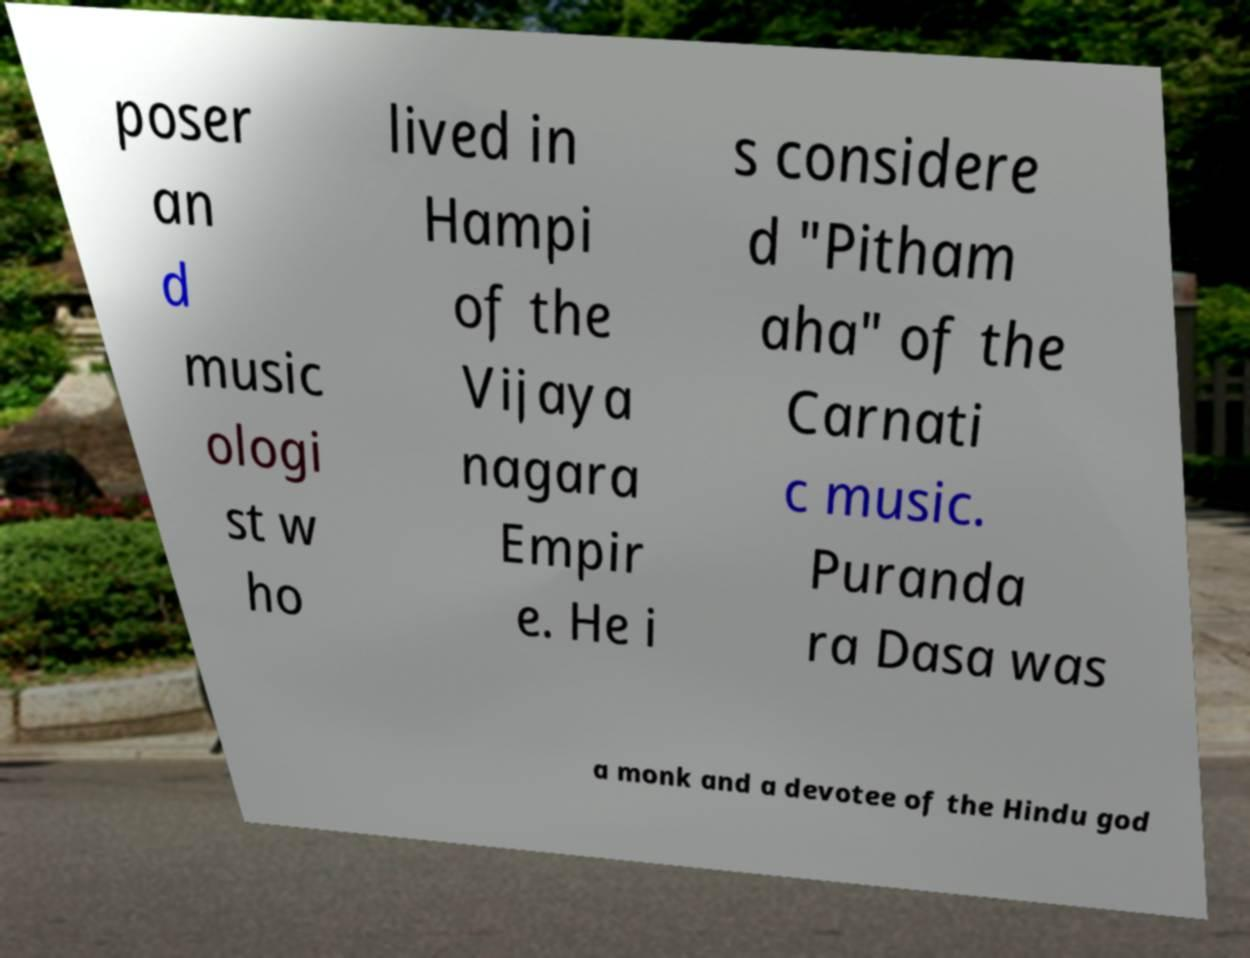Can you accurately transcribe the text from the provided image for me? poser an d music ologi st w ho lived in Hampi of the Vijaya nagara Empir e. He i s considere d "Pitham aha" of the Carnati c music. Puranda ra Dasa was a monk and a devotee of the Hindu god 